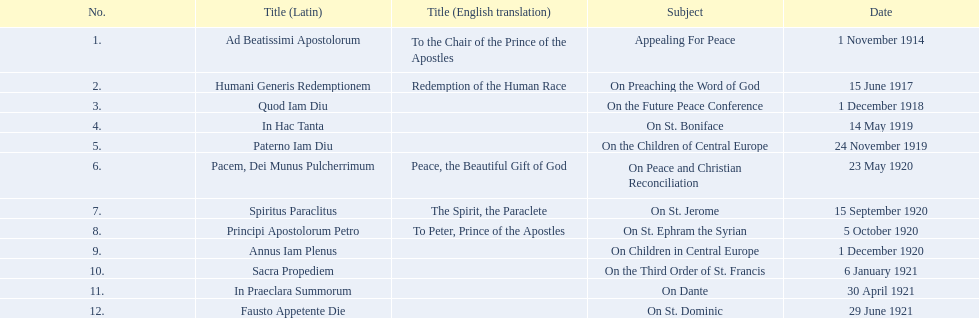What are the complete list of subjects? Appealing For Peace, On Preaching the Word of God, On the Future Peace Conference, On St. Boniface, On the Children of Central Europe, On Peace and Christian Reconciliation, On St. Jerome, On St. Ephram the Syrian, On Children in Central Europe, On the Third Order of St. Francis, On Dante, On St. Dominic. What are the dates for each? 1 November 1914, 15 June 1917, 1 December 1918, 14 May 1919, 24 November 1919, 23 May 1920, 15 September 1920, 5 October 1920, 1 December 1920, 6 January 1921, 30 April 1921, 29 June 1921. Which subject has a date of 23 may 1920? On Peace and Christian Reconciliation. 